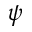<formula> <loc_0><loc_0><loc_500><loc_500>\psi</formula> 